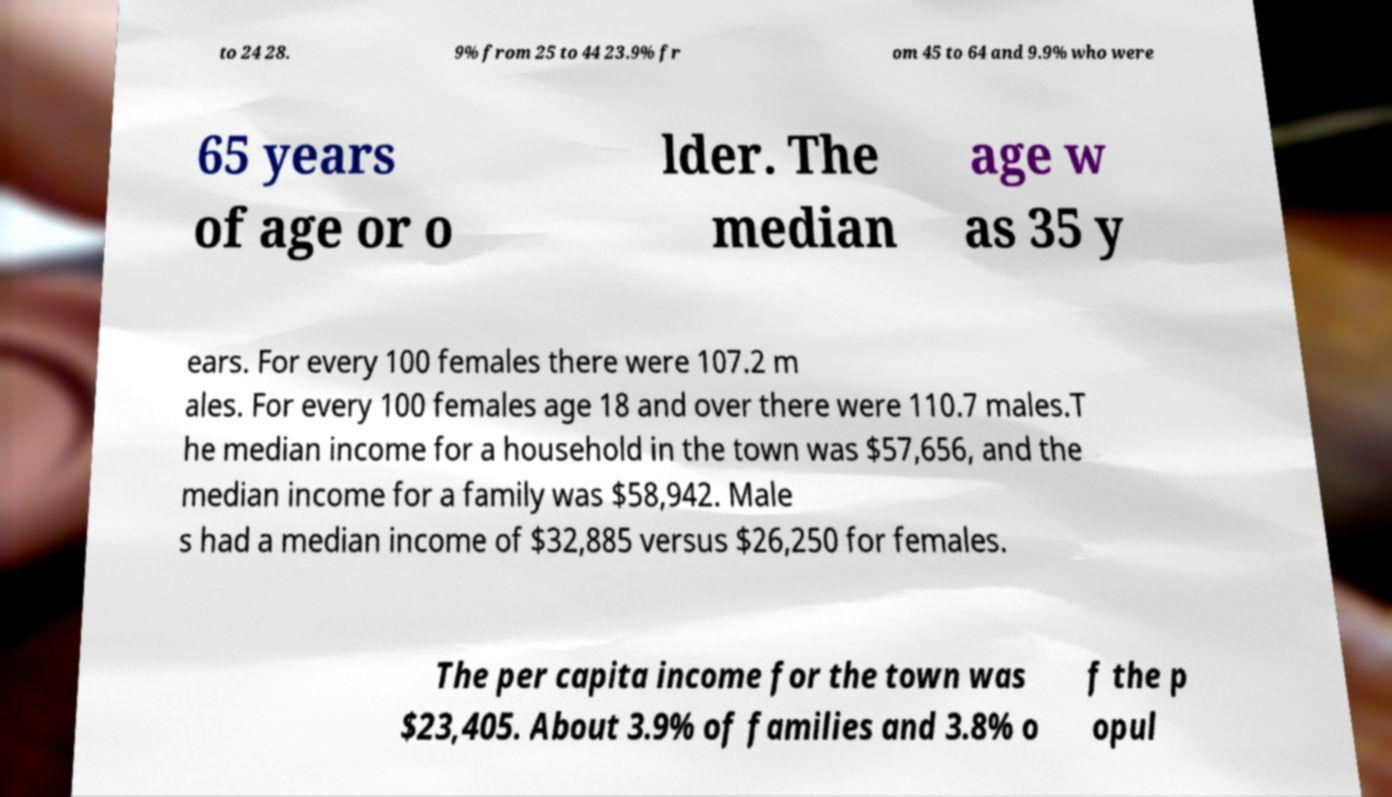What messages or text are displayed in this image? I need them in a readable, typed format. to 24 28. 9% from 25 to 44 23.9% fr om 45 to 64 and 9.9% who were 65 years of age or o lder. The median age w as 35 y ears. For every 100 females there were 107.2 m ales. For every 100 females age 18 and over there were 110.7 males.T he median income for a household in the town was $57,656, and the median income for a family was $58,942. Male s had a median income of $32,885 versus $26,250 for females. The per capita income for the town was $23,405. About 3.9% of families and 3.8% o f the p opul 